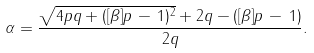Convert formula to latex. <formula><loc_0><loc_0><loc_500><loc_500>\alpha = \frac { \sqrt { 4 p q + ( [ \beta ] p \, - \, 1 ) ^ { 2 } } + 2 q - ( [ \beta ] p \, - \, 1 ) } { 2 q } .</formula> 